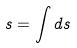Convert formula to latex. <formula><loc_0><loc_0><loc_500><loc_500>s = \int d s</formula> 